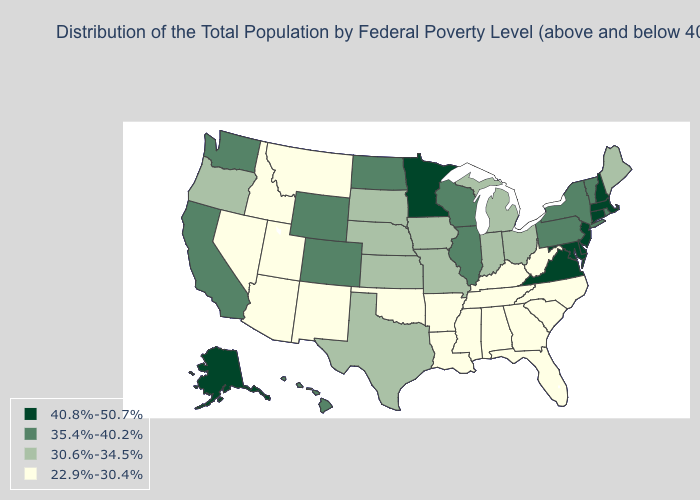What is the value of Oklahoma?
Keep it brief. 22.9%-30.4%. What is the lowest value in states that border Rhode Island?
Answer briefly. 40.8%-50.7%. What is the lowest value in the USA?
Be succinct. 22.9%-30.4%. Does Washington have a lower value than Wyoming?
Concise answer only. No. Among the states that border South Dakota , does Montana have the lowest value?
Short answer required. Yes. Which states hav the highest value in the South?
Write a very short answer. Delaware, Maryland, Virginia. What is the value of Maryland?
Give a very brief answer. 40.8%-50.7%. What is the value of Idaho?
Write a very short answer. 22.9%-30.4%. Which states have the highest value in the USA?
Keep it brief. Alaska, Connecticut, Delaware, Maryland, Massachusetts, Minnesota, New Hampshire, New Jersey, Virginia. Name the states that have a value in the range 30.6%-34.5%?
Keep it brief. Indiana, Iowa, Kansas, Maine, Michigan, Missouri, Nebraska, Ohio, Oregon, South Dakota, Texas. Does Louisiana have the highest value in the USA?
Concise answer only. No. Does the map have missing data?
Answer briefly. No. Among the states that border South Carolina , which have the lowest value?
Concise answer only. Georgia, North Carolina. What is the value of Oklahoma?
Concise answer only. 22.9%-30.4%. What is the value of Idaho?
Short answer required. 22.9%-30.4%. 